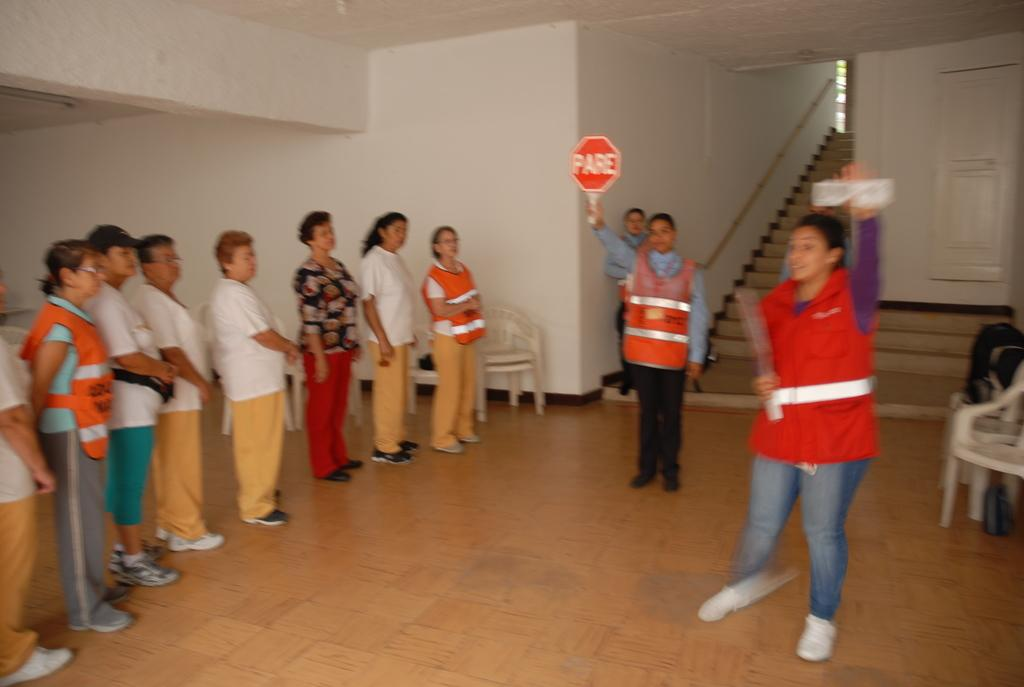<image>
Relay a brief, clear account of the picture shown. People in a line wearing vests looking at a sign that says PARE. 